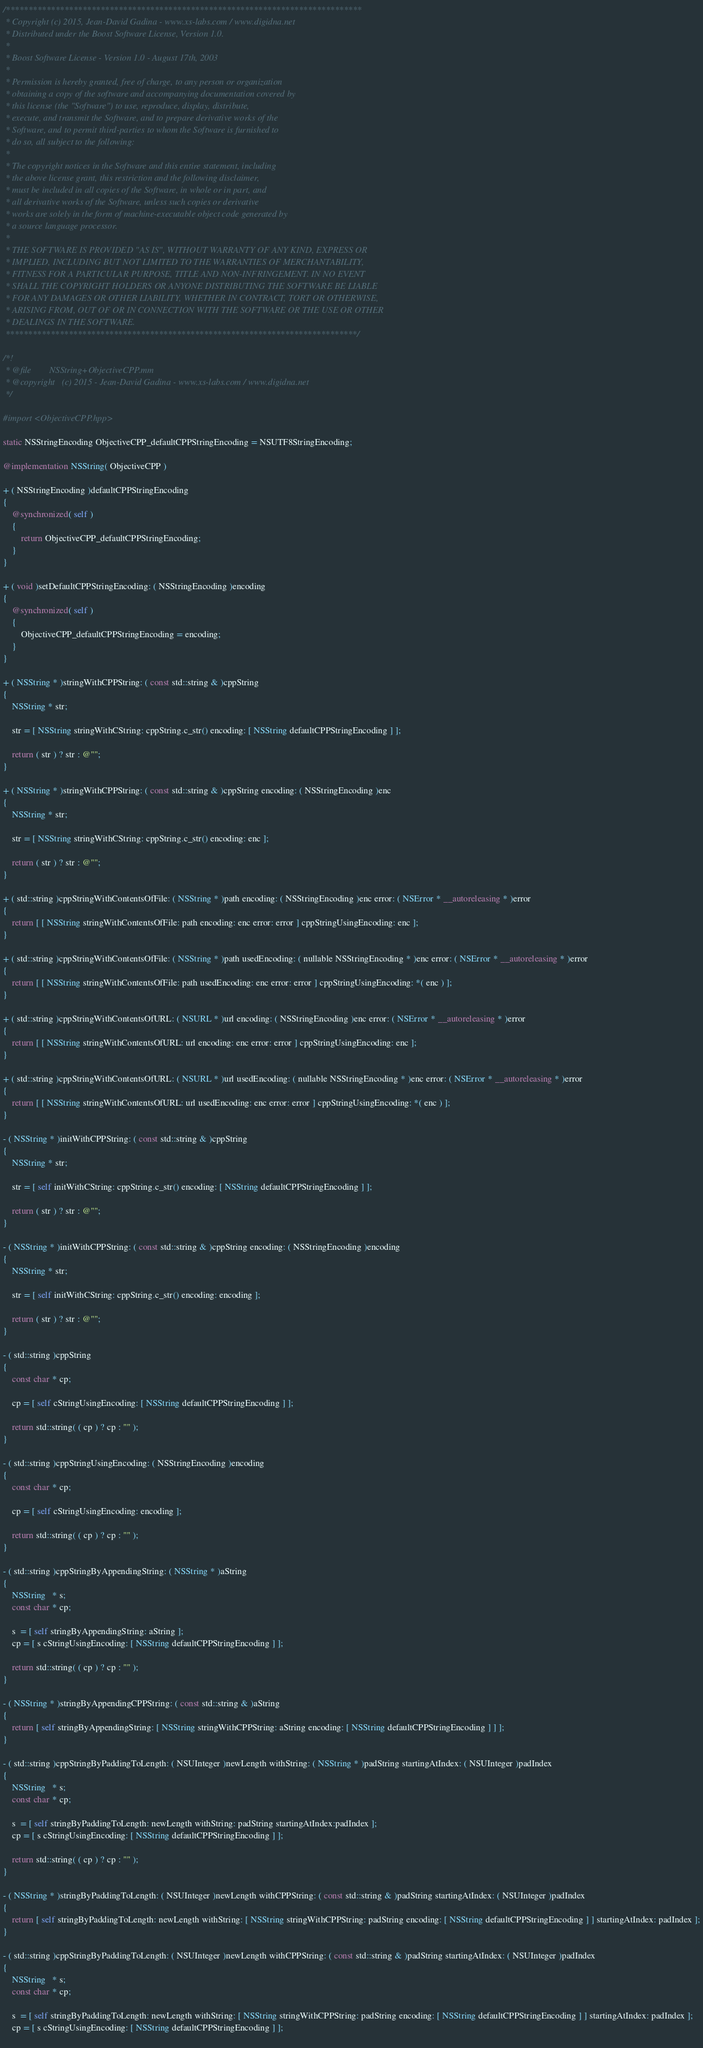<code> <loc_0><loc_0><loc_500><loc_500><_ObjectiveC_>/*******************************************************************************
 * Copyright (c) 2015, Jean-David Gadina - www.xs-labs.com / www.digidna.net
 * Distributed under the Boost Software License, Version 1.0.
 * 
 * Boost Software License - Version 1.0 - August 17th, 2003
 * 
 * Permission is hereby granted, free of charge, to any person or organization
 * obtaining a copy of the software and accompanying documentation covered by
 * this license (the "Software") to use, reproduce, display, distribute,
 * execute, and transmit the Software, and to prepare derivative works of the
 * Software, and to permit third-parties to whom the Software is furnished to
 * do so, all subject to the following:
 * 
 * The copyright notices in the Software and this entire statement, including
 * the above license grant, this restriction and the following disclaimer,
 * must be included in all copies of the Software, in whole or in part, and
 * all derivative works of the Software, unless such copies or derivative
 * works are solely in the form of machine-executable object code generated by
 * a source language processor.
 * 
 * THE SOFTWARE IS PROVIDED "AS IS", WITHOUT WARRANTY OF ANY KIND, EXPRESS OR
 * IMPLIED, INCLUDING BUT NOT LIMITED TO THE WARRANTIES OF MERCHANTABILITY,
 * FITNESS FOR A PARTICULAR PURPOSE, TITLE AND NON-INFRINGEMENT. IN NO EVENT
 * SHALL THE COPYRIGHT HOLDERS OR ANYONE DISTRIBUTING THE SOFTWARE BE LIABLE
 * FOR ANY DAMAGES OR OTHER LIABILITY, WHETHER IN CONTRACT, TORT OR OTHERWISE,
 * ARISING FROM, OUT OF OR IN CONNECTION WITH THE SOFTWARE OR THE USE OR OTHER
 * DEALINGS IN THE SOFTWARE.
 ******************************************************************************/

/*!
 * @file        NSString+ObjectiveCPP.mm
 * @copyright   (c) 2015 - Jean-David Gadina - www.xs-labs.com / www.digidna.net
 */

#import <ObjectiveCPP.hpp>

static NSStringEncoding ObjectiveCPP_defaultCPPStringEncoding = NSUTF8StringEncoding;

@implementation NSString( ObjectiveCPP )

+ ( NSStringEncoding )defaultCPPStringEncoding
{
    @synchronized( self )
    {
        return ObjectiveCPP_defaultCPPStringEncoding;
    }
}

+ ( void )setDefaultCPPStringEncoding: ( NSStringEncoding )encoding
{
    @synchronized( self )
    {
        ObjectiveCPP_defaultCPPStringEncoding = encoding;
    }
}

+ ( NSString * )stringWithCPPString: ( const std::string & )cppString
{
    NSString * str;
    
    str = [ NSString stringWithCString: cppString.c_str() encoding: [ NSString defaultCPPStringEncoding ] ];
    
    return ( str ) ? str : @"";
}

+ ( NSString * )stringWithCPPString: ( const std::string & )cppString encoding: ( NSStringEncoding )enc
{
    NSString * str;
    
    str = [ NSString stringWithCString: cppString.c_str() encoding: enc ];
    
    return ( str ) ? str : @"";
}

+ ( std::string )cppStringWithContentsOfFile: ( NSString * )path encoding: ( NSStringEncoding )enc error: ( NSError * __autoreleasing * )error
{
    return [ [ NSString stringWithContentsOfFile: path encoding: enc error: error ] cppStringUsingEncoding: enc ];
}

+ ( std::string )cppStringWithContentsOfFile: ( NSString * )path usedEncoding: ( nullable NSStringEncoding * )enc error: ( NSError * __autoreleasing * )error
{
    return [ [ NSString stringWithContentsOfFile: path usedEncoding: enc error: error ] cppStringUsingEncoding: *( enc ) ];
}

+ ( std::string )cppStringWithContentsOfURL: ( NSURL * )url encoding: ( NSStringEncoding )enc error: ( NSError * __autoreleasing * )error
{
    return [ [ NSString stringWithContentsOfURL: url encoding: enc error: error ] cppStringUsingEncoding: enc ];
}

+ ( std::string )cppStringWithContentsOfURL: ( NSURL * )url usedEncoding: ( nullable NSStringEncoding * )enc error: ( NSError * __autoreleasing * )error
{
    return [ [ NSString stringWithContentsOfURL: url usedEncoding: enc error: error ] cppStringUsingEncoding: *( enc ) ];
}

- ( NSString * )initWithCPPString: ( const std::string & )cppString
{
    NSString * str;
    
    str = [ self initWithCString: cppString.c_str() encoding: [ NSString defaultCPPStringEncoding ] ];
    
    return ( str ) ? str : @"";
}

- ( NSString * )initWithCPPString: ( const std::string & )cppString encoding: ( NSStringEncoding )encoding
{
    NSString * str;
    
    str = [ self initWithCString: cppString.c_str() encoding: encoding ];
    
    return ( str ) ? str : @"";
}

- ( std::string )cppString
{
    const char * cp;
    
    cp = [ self cStringUsingEncoding: [ NSString defaultCPPStringEncoding ] ];
    
    return std::string( ( cp ) ? cp : "" );
}

- ( std::string )cppStringUsingEncoding: ( NSStringEncoding )encoding
{
    const char * cp;
    
    cp = [ self cStringUsingEncoding: encoding ];
    
    return std::string( ( cp ) ? cp : "" );
}

- ( std::string )cppStringByAppendingString: ( NSString * )aString
{
    NSString   * s;
    const char * cp;
    
    s  = [ self stringByAppendingString: aString ];
    cp = [ s cStringUsingEncoding: [ NSString defaultCPPStringEncoding ] ];
    
    return std::string( ( cp ) ? cp : "" );
}

- ( NSString * )stringByAppendingCPPString: ( const std::string & )aString
{
    return [ self stringByAppendingString: [ NSString stringWithCPPString: aString encoding: [ NSString defaultCPPStringEncoding ] ] ];
}

- ( std::string )cppStringByPaddingToLength: ( NSUInteger )newLength withString: ( NSString * )padString startingAtIndex: ( NSUInteger )padIndex
{
    NSString   * s;
    const char * cp;
    
    s  = [ self stringByPaddingToLength: newLength withString: padString startingAtIndex:padIndex ];
    cp = [ s cStringUsingEncoding: [ NSString defaultCPPStringEncoding ] ];
    
    return std::string( ( cp ) ? cp : "" );
}

- ( NSString * )stringByPaddingToLength: ( NSUInteger )newLength withCPPString: ( const std::string & )padString startingAtIndex: ( NSUInteger )padIndex
{
    return [ self stringByPaddingToLength: newLength withString: [ NSString stringWithCPPString: padString encoding: [ NSString defaultCPPStringEncoding ] ] startingAtIndex: padIndex ];
}

- ( std::string )cppStringByPaddingToLength: ( NSUInteger )newLength withCPPString: ( const std::string & )padString startingAtIndex: ( NSUInteger )padIndex
{
    NSString   * s;
    const char * cp;
    
    s  = [ self stringByPaddingToLength: newLength withString: [ NSString stringWithCPPString: padString encoding: [ NSString defaultCPPStringEncoding ] ] startingAtIndex: padIndex ];
    cp = [ s cStringUsingEncoding: [ NSString defaultCPPStringEncoding ] ];
    </code> 